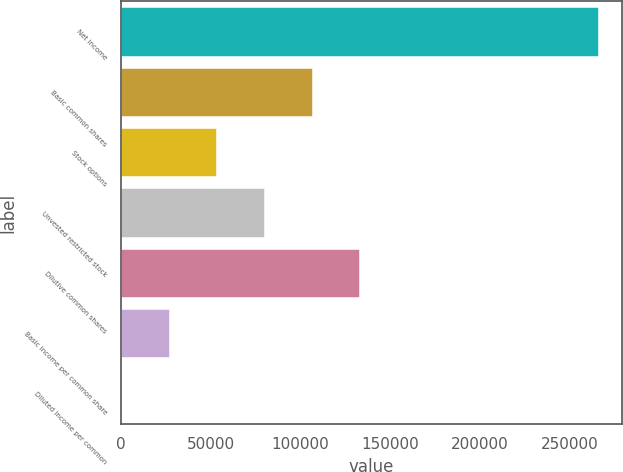<chart> <loc_0><loc_0><loc_500><loc_500><bar_chart><fcel>Net income<fcel>Basic common shares<fcel>Stock options<fcel>Unvested restricted stock<fcel>Dilutive common shares<fcel>Basic income per common share<fcel>Diluted income per common<nl><fcel>265895<fcel>106360<fcel>53181.1<fcel>79770.3<fcel>132949<fcel>26591.8<fcel>2.6<nl></chart> 